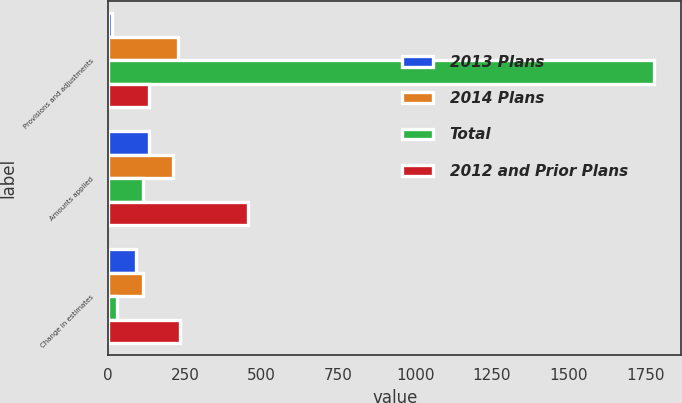<chart> <loc_0><loc_0><loc_500><loc_500><stacked_bar_chart><ecel><fcel>Provisions and adjustments<fcel>Amounts applied<fcel>Change in estimates<nl><fcel>2013 Plans<fcel>11<fcel>132<fcel>92<nl><fcel>2014 Plans<fcel>226<fcel>211<fcel>113<nl><fcel>Total<fcel>1779<fcel>113<fcel>30<nl><fcel>2012 and Prior Plans<fcel>132<fcel>456<fcel>235<nl></chart> 